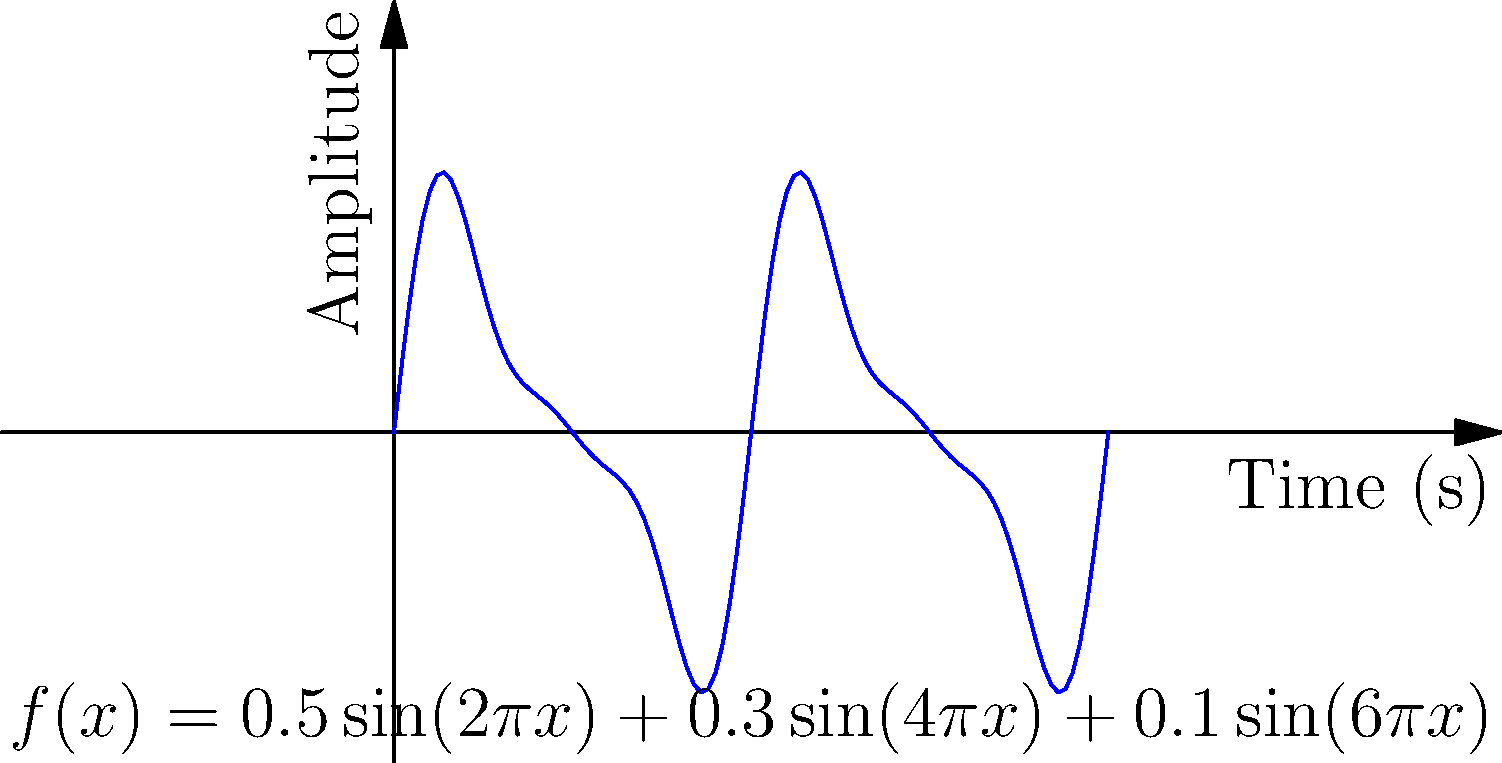The graph above represents the sound wave of an operatic aria, modeled by the polynomial function $f(x) = 0.5\sin(2\pi x) + 0.3\sin(4\pi x) + 0.1\sin(6\pi x)$, where $x$ is time in seconds and $f(x)$ is the amplitude. What is the fundamental frequency of this aria in Hertz (Hz)? To find the fundamental frequency, we need to follow these steps:

1) The fundamental frequency is determined by the lowest frequency component in the function.

2) In the given function $f(x) = 0.5\sin(2\pi x) + 0.3\sin(4\pi x) + 0.1\sin(6\pi x)$, we have three sine terms:
   - $0.5\sin(2\pi x)$
   - $0.3\sin(4\pi x)$
   - $0.1\sin(6\pi x)$

3) The general form of a sine function is $\sin(2\pi ft)$, where $f$ is the frequency and $t$ is time.

4) Comparing our terms to this general form:
   - $2\pi x$ corresponds to $2\pi ft$, so $f = 1$ Hz
   - $4\pi x$ corresponds to $2\pi ft$, so $f = 2$ Hz
   - $6\pi x$ corresponds to $2\pi ft$, so $f = 3$ Hz

5) The lowest frequency among these is 1 Hz.

Therefore, the fundamental frequency of this aria is 1 Hz.
Answer: 1 Hz 